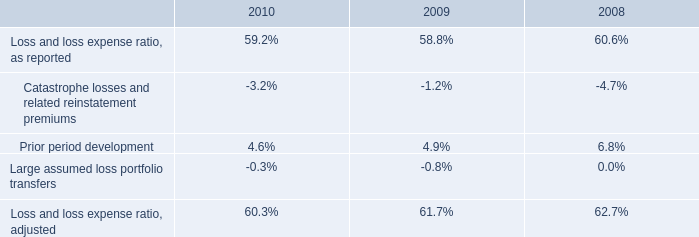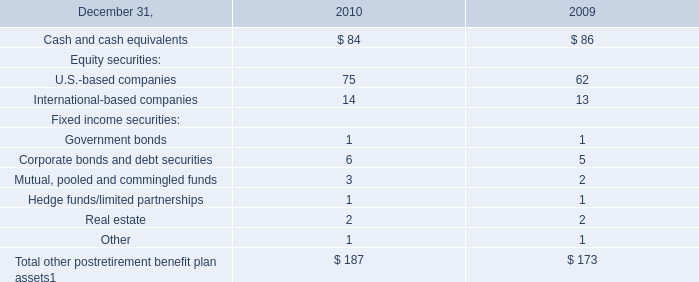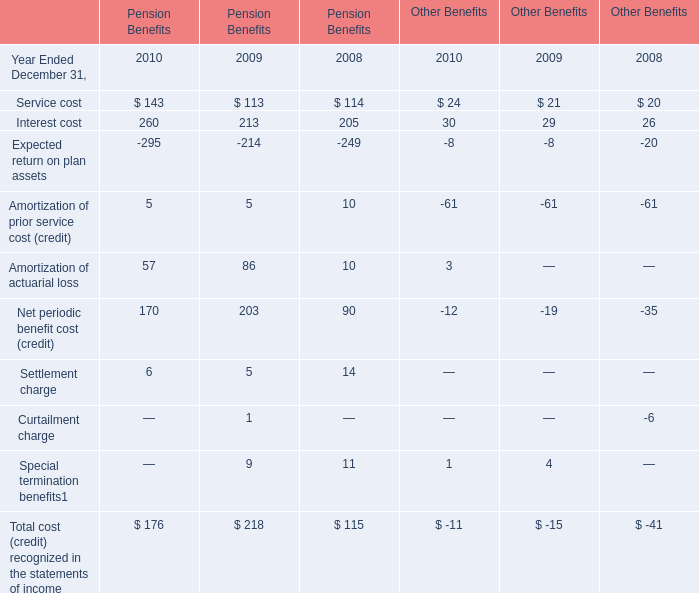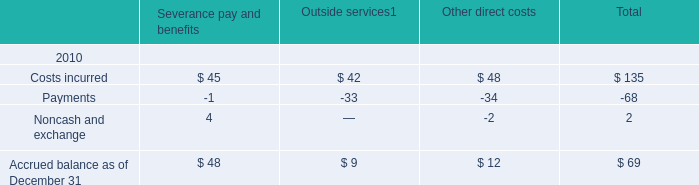by what amount have catastrophic losses in 2010 surpass the catastrophic losses of 2009 , ( in millions ) ? 
Computations: (366 - 137)
Answer: 229.0. 